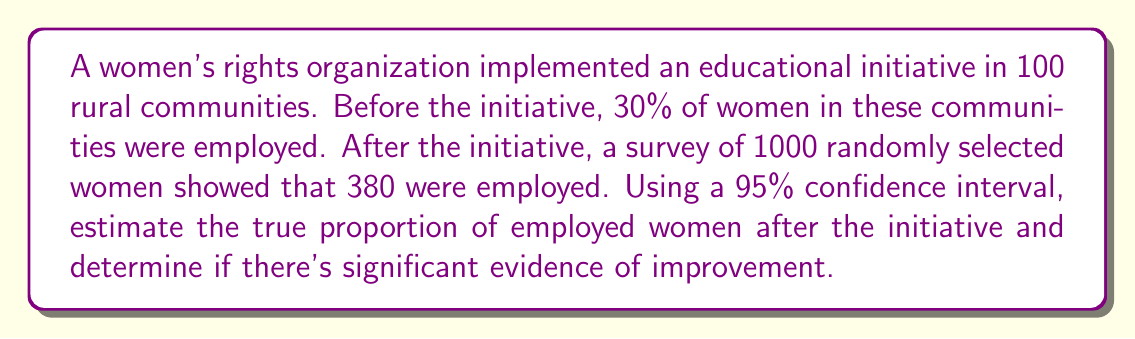Help me with this question. 1. Calculate the sample proportion:
   $\hat{p} = \frac{380}{1000} = 0.38$

2. Calculate the standard error:
   $SE = \sqrt{\frac{\hat{p}(1-\hat{p})}{n}} = \sqrt{\frac{0.38(1-0.38)}{1000}} \approx 0.0153$

3. For a 95% confidence interval, use $z = 1.96$

4. Calculate the margin of error:
   $ME = z \times SE = 1.96 \times 0.0153 \approx 0.0300$

5. Construct the confidence interval:
   $CI = \hat{p} \pm ME = 0.38 \pm 0.0300 = (0.35, 0.41)$

6. Compare with the initial proportion:
   The initial proportion (0.30) is not within the confidence interval (0.35, 0.41).

7. Conclusion:
   Since the initial proportion is outside the confidence interval, there is significant evidence at the 95% confidence level that the proportion of employed women has increased after the educational initiative.
Answer: (0.35, 0.41); Significant improvement 